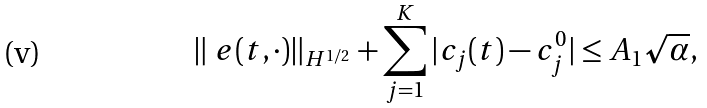<formula> <loc_0><loc_0><loc_500><loc_500>\| \ e ( t , \cdot ) \| _ { H ^ { 1 / 2 } } + \sum _ { j = 1 } ^ { K } | c _ { j } ( t ) - c _ { j } ^ { 0 } | \leq A _ { 1 } \sqrt { \alpha } ,</formula> 